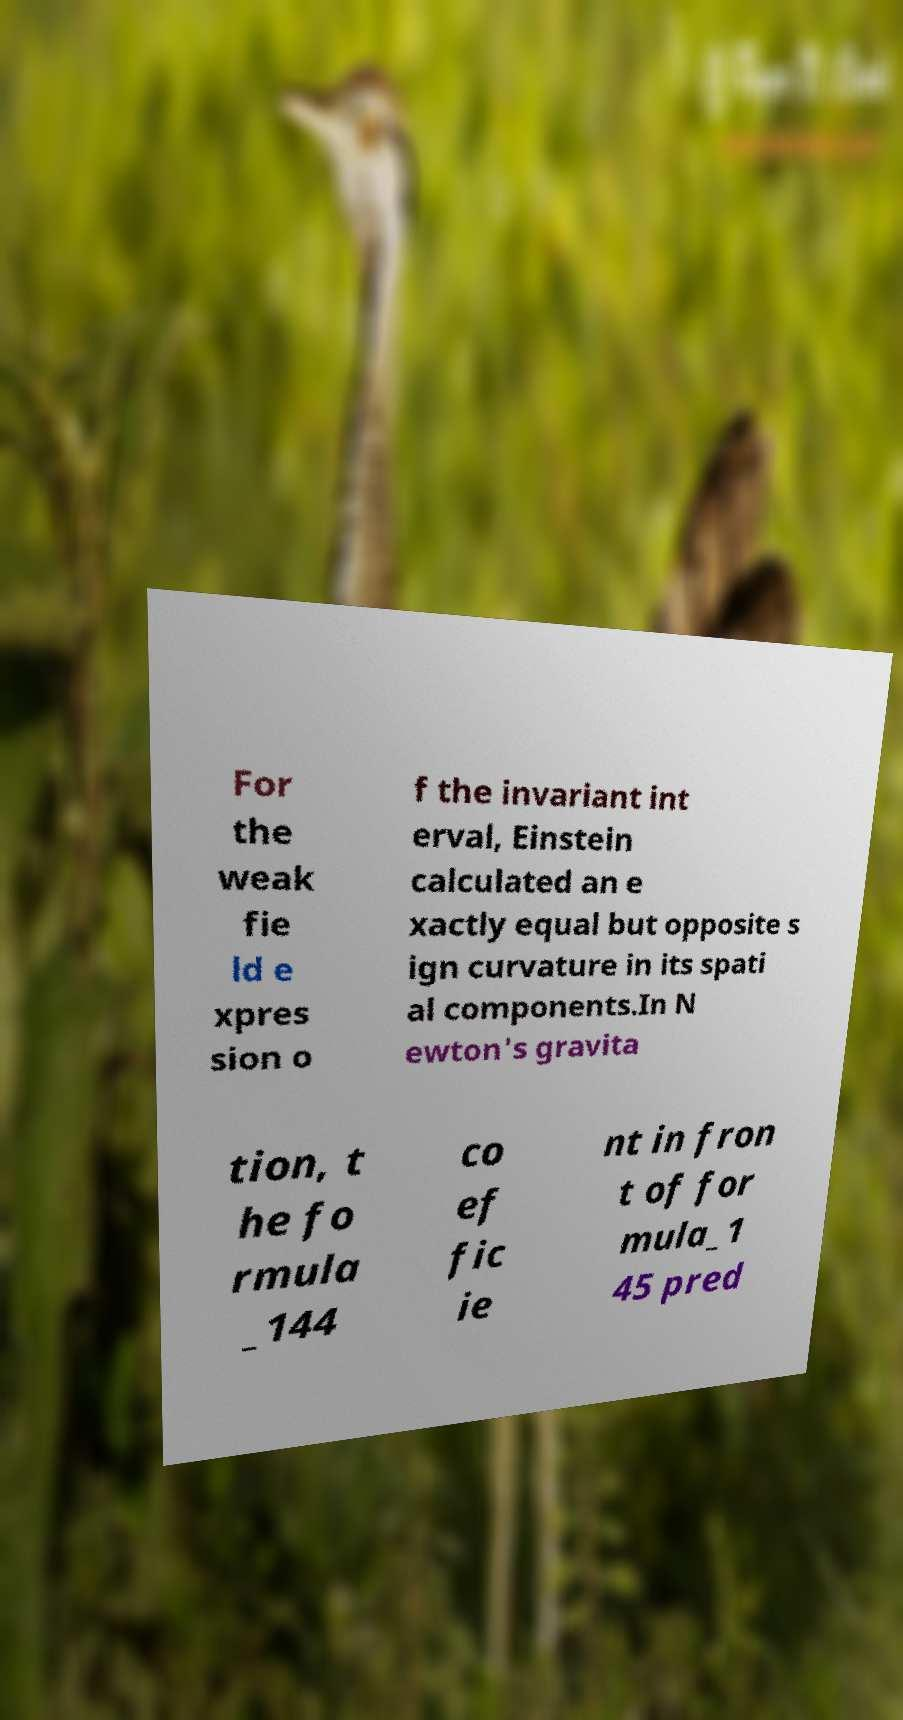Can you accurately transcribe the text from the provided image for me? For the weak fie ld e xpres sion o f the invariant int erval, Einstein calculated an e xactly equal but opposite s ign curvature in its spati al components.In N ewton's gravita tion, t he fo rmula _144 co ef fic ie nt in fron t of for mula_1 45 pred 